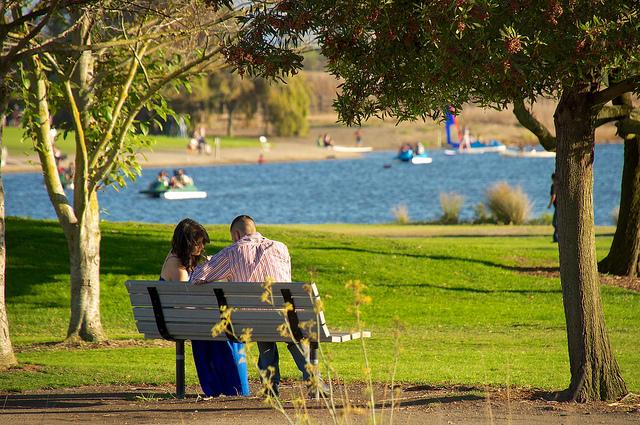What type of trees are the people on the bench facing?
Short answer required. Elm. How many people are in the image?
Concise answer only. 2. How many boats are sailing?
Short answer required. 4. What color is the woman's dress?
Keep it brief. Blue. What is the couple sitting on?
Concise answer only. Bench. 